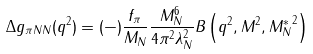<formula> <loc_0><loc_0><loc_500><loc_500>\Delta g _ { \pi N N } ( q ^ { 2 } ) = ( - ) \frac { f _ { \pi } } { M _ { N } } \frac { M _ { N } ^ { 6 } } { 4 \pi ^ { 2 } \lambda _ { N } ^ { 2 } } B \left ( q ^ { 2 } , M ^ { 2 } , { M _ { N } ^ { * } } ^ { 2 } \right )</formula> 